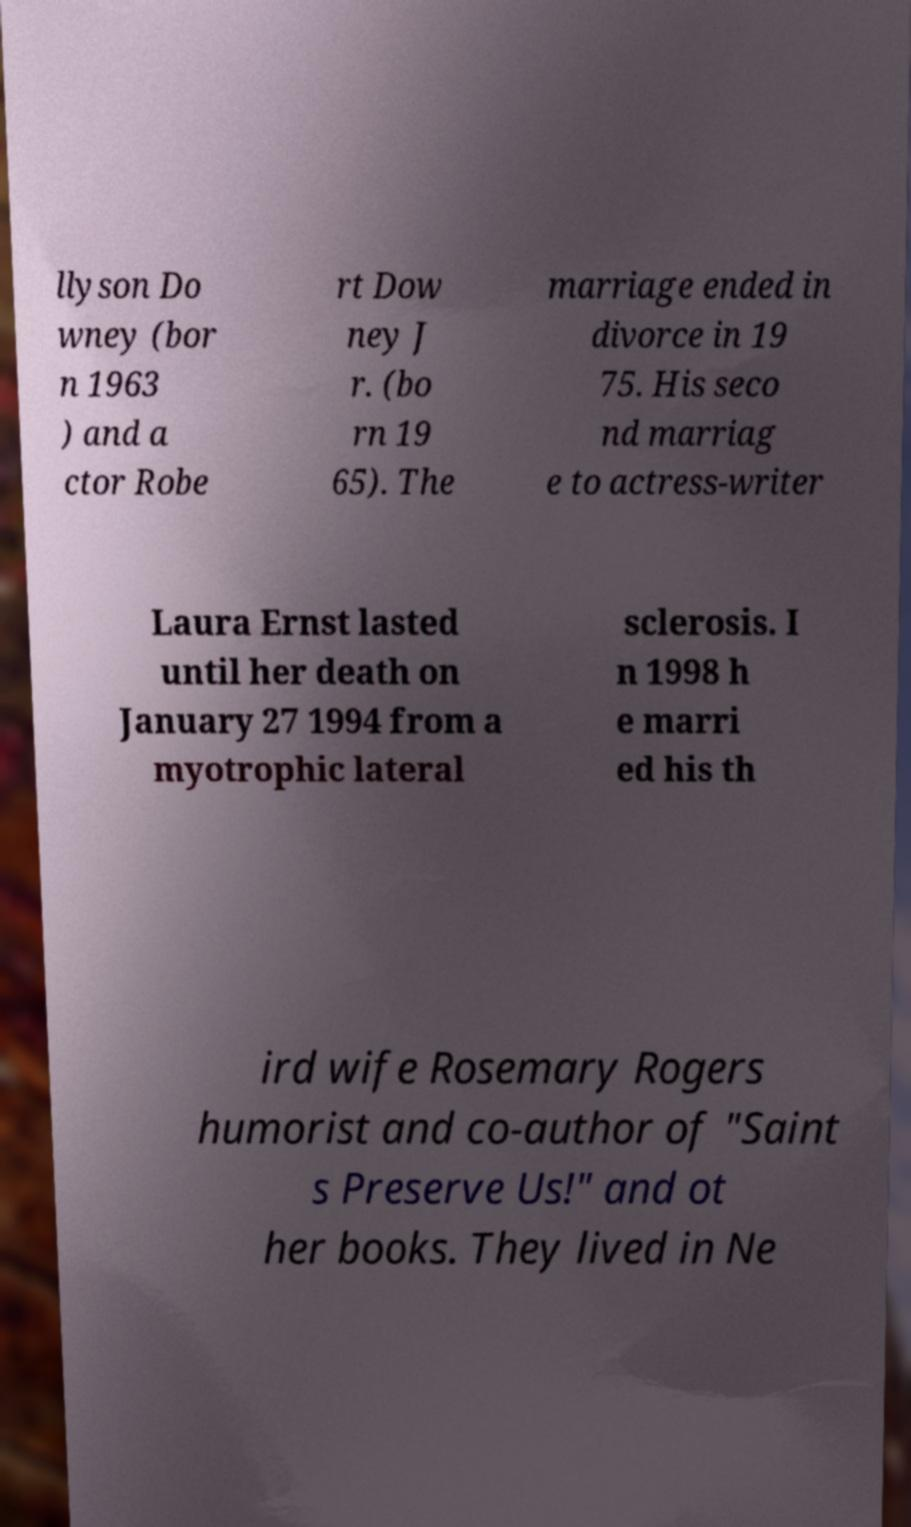There's text embedded in this image that I need extracted. Can you transcribe it verbatim? llyson Do wney (bor n 1963 ) and a ctor Robe rt Dow ney J r. (bo rn 19 65). The marriage ended in divorce in 19 75. His seco nd marriag e to actress-writer Laura Ernst lasted until her death on January 27 1994 from a myotrophic lateral sclerosis. I n 1998 h e marri ed his th ird wife Rosemary Rogers humorist and co-author of "Saint s Preserve Us!" and ot her books. They lived in Ne 